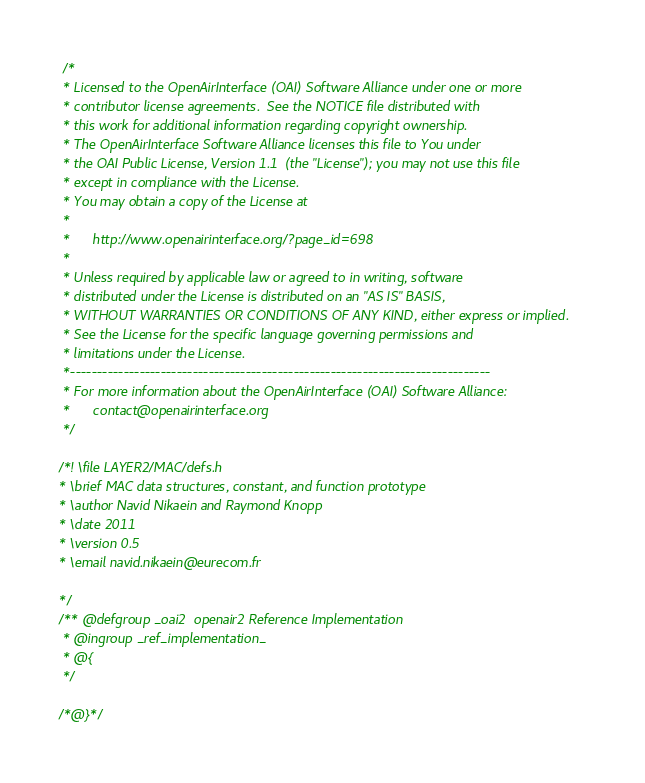<code> <loc_0><loc_0><loc_500><loc_500><_C_> /*
 * Licensed to the OpenAirInterface (OAI) Software Alliance under one or more
 * contributor license agreements.  See the NOTICE file distributed with
 * this work for additional information regarding copyright ownership.
 * The OpenAirInterface Software Alliance licenses this file to You under
 * the OAI Public License, Version 1.1  (the "License"); you may not use this file
 * except in compliance with the License.
 * You may obtain a copy of the License at
 *
 *      http://www.openairinterface.org/?page_id=698
 *
 * Unless required by applicable law or agreed to in writing, software
 * distributed under the License is distributed on an "AS IS" BASIS,
 * WITHOUT WARRANTIES OR CONDITIONS OF ANY KIND, either express or implied.
 * See the License for the specific language governing permissions and
 * limitations under the License.
 *-------------------------------------------------------------------------------
 * For more information about the OpenAirInterface (OAI) Software Alliance:
 *      contact@openairinterface.org
 */

/*! \file LAYER2/MAC/defs.h
* \brief MAC data structures, constant, and function prototype
* \author Navid Nikaein and Raymond Knopp
* \date 2011
* \version 0.5
* \email navid.nikaein@eurecom.fr

*/
/** @defgroup _oai2  openair2 Reference Implementation
 * @ingroup _ref_implementation_
 * @{
 */

/*@}*/
</code> 